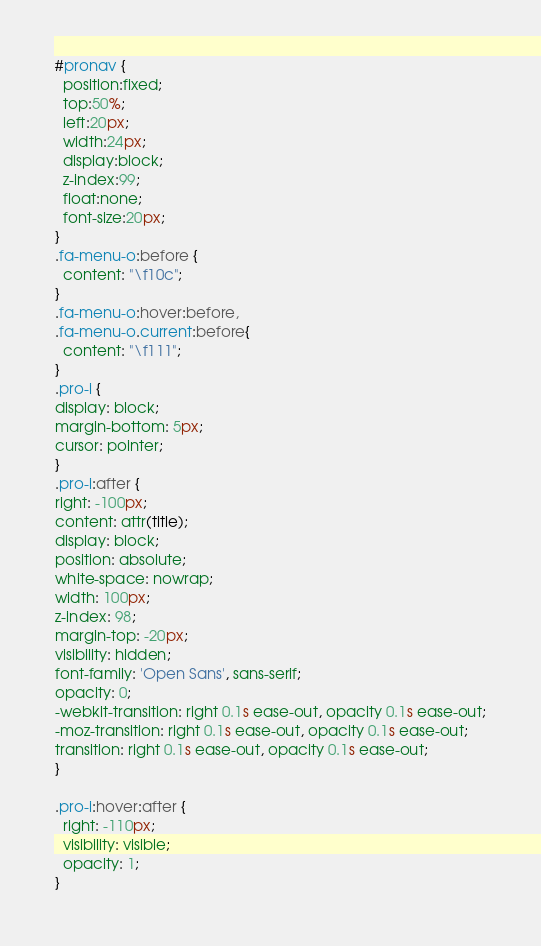<code> <loc_0><loc_0><loc_500><loc_500><_CSS_>#pronav {
  position:fixed;
  top:50%;
  left:20px;
  width:24px;
  display:block;
  z-index:99;
  float:none;
  font-size:20px;
}
.fa-menu-o:before {
  content: "\f10c";
}
.fa-menu-o:hover:before,
.fa-menu-o.current:before{
  content: "\f111";
}
.pro-i {
display: block;
margin-bottom: 5px;
cursor: pointer;
}
.pro-i:after {
right: -100px;
content: attr(title);
display: block;
position: absolute;
white-space: nowrap;
width: 100px;
z-index: 98;
margin-top: -20px;
visibility: hidden;
font-family: 'Open Sans', sans-serif;
opacity: 0;
-webkit-transition: right 0.1s ease-out, opacity 0.1s ease-out;
-moz-transition: right 0.1s ease-out, opacity 0.1s ease-out;
transition: right 0.1s ease-out, opacity 0.1s ease-out;
}

.pro-i:hover:after {
  right: -110px;
  visibility: visible;
  opacity: 1;
}

</code> 